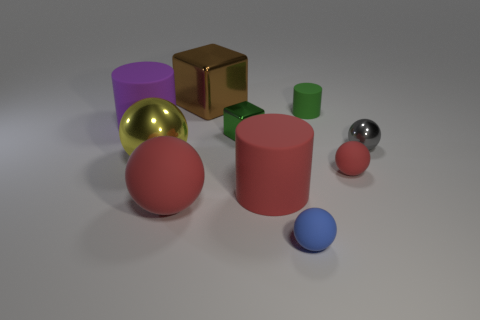Subtract all yellow metallic spheres. How many spheres are left? 4 Subtract all blue balls. How many balls are left? 4 Subtract all purple balls. Subtract all green cylinders. How many balls are left? 5 Subtract all cubes. How many objects are left? 8 Add 4 big metallic spheres. How many big metallic spheres are left? 5 Add 8 gray spheres. How many gray spheres exist? 9 Subtract 1 green cubes. How many objects are left? 9 Subtract all small yellow spheres. Subtract all spheres. How many objects are left? 5 